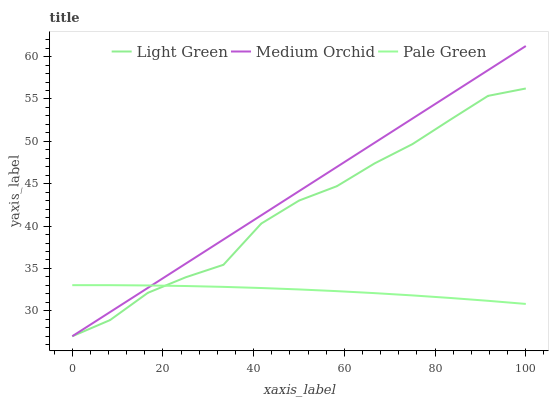Does Pale Green have the minimum area under the curve?
Answer yes or no. Yes. Does Medium Orchid have the maximum area under the curve?
Answer yes or no. Yes. Does Light Green have the minimum area under the curve?
Answer yes or no. No. Does Light Green have the maximum area under the curve?
Answer yes or no. No. Is Medium Orchid the smoothest?
Answer yes or no. Yes. Is Light Green the roughest?
Answer yes or no. Yes. Is Light Green the smoothest?
Answer yes or no. No. Is Medium Orchid the roughest?
Answer yes or no. No. Does Light Green have the highest value?
Answer yes or no. No. 